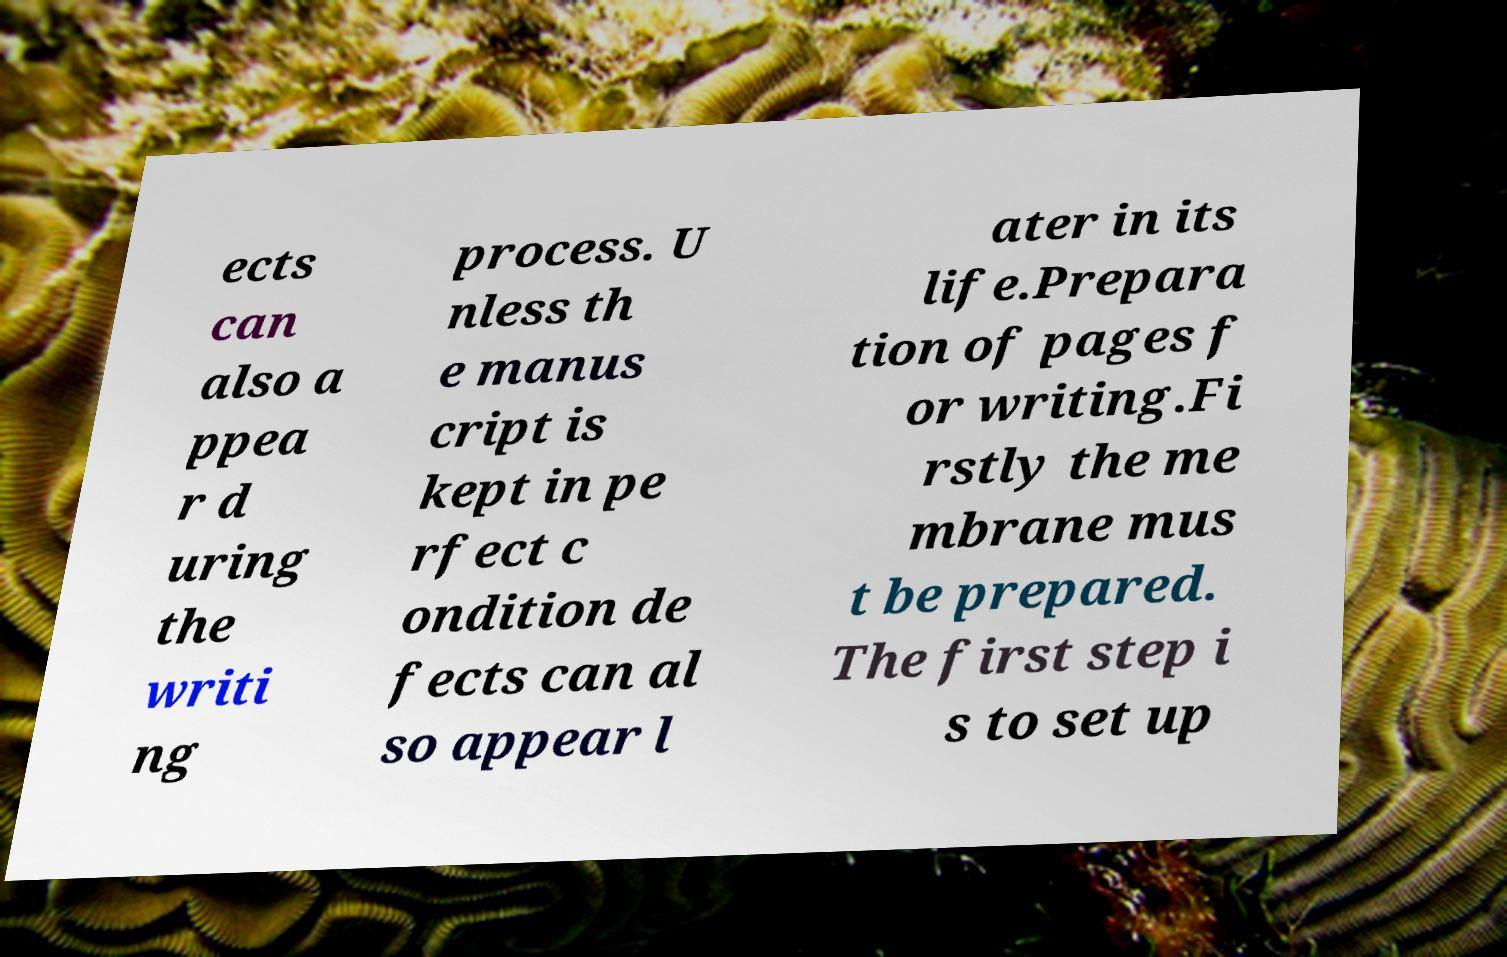Can you accurately transcribe the text from the provided image for me? ects can also a ppea r d uring the writi ng process. U nless th e manus cript is kept in pe rfect c ondition de fects can al so appear l ater in its life.Prepara tion of pages f or writing.Fi rstly the me mbrane mus t be prepared. The first step i s to set up 